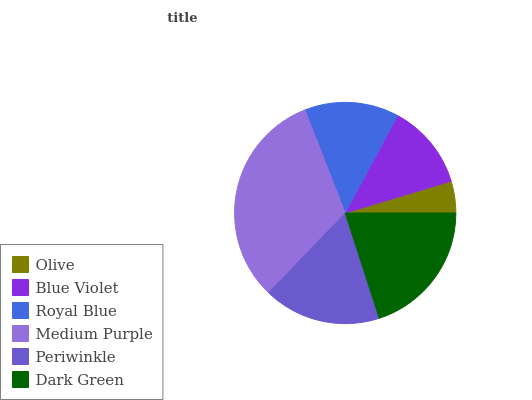Is Olive the minimum?
Answer yes or no. Yes. Is Medium Purple the maximum?
Answer yes or no. Yes. Is Blue Violet the minimum?
Answer yes or no. No. Is Blue Violet the maximum?
Answer yes or no. No. Is Blue Violet greater than Olive?
Answer yes or no. Yes. Is Olive less than Blue Violet?
Answer yes or no. Yes. Is Olive greater than Blue Violet?
Answer yes or no. No. Is Blue Violet less than Olive?
Answer yes or no. No. Is Periwinkle the high median?
Answer yes or no. Yes. Is Royal Blue the low median?
Answer yes or no. Yes. Is Blue Violet the high median?
Answer yes or no. No. Is Periwinkle the low median?
Answer yes or no. No. 